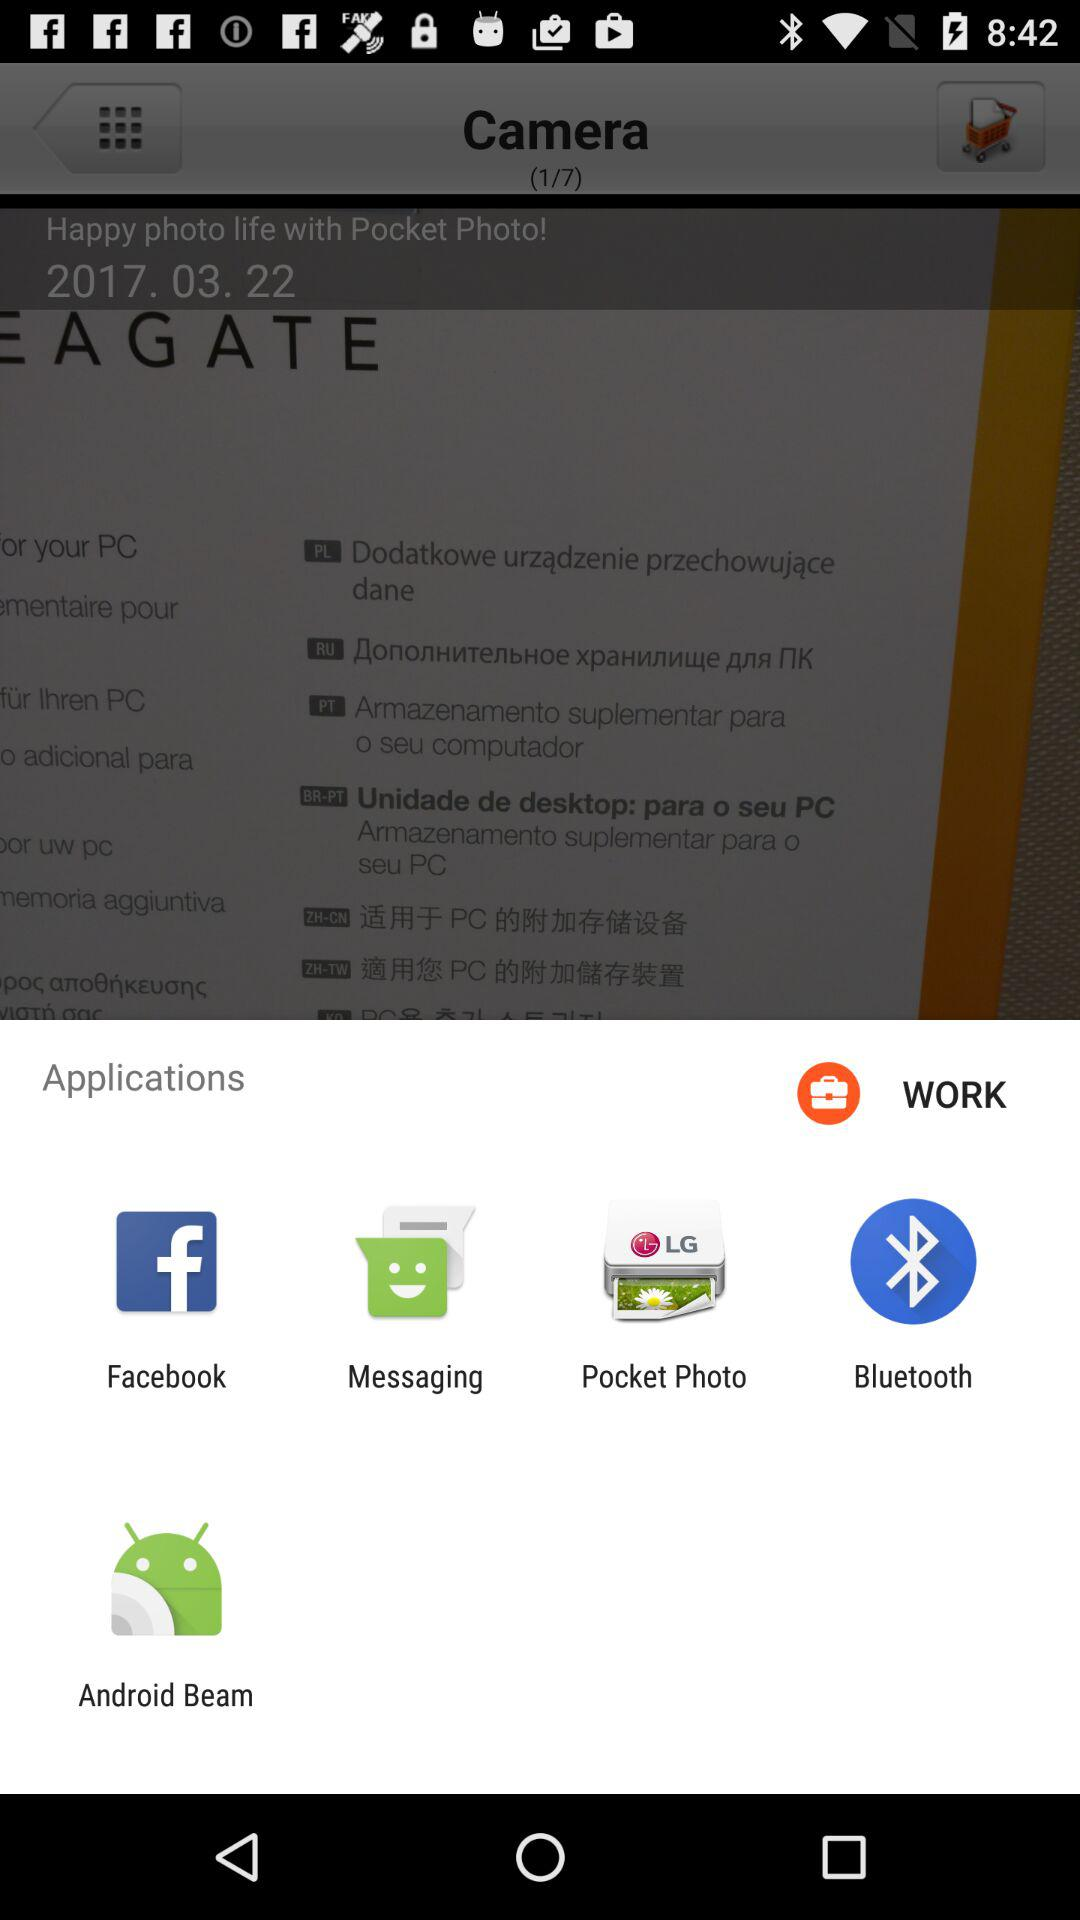Through what applications can we share the image? The applications are "Facebook", "Messaging", "Pocket Photo", "Bluetooth", and "Android Beam". 